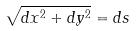Convert formula to latex. <formula><loc_0><loc_0><loc_500><loc_500>\sqrt { d x ^ { 2 } + d y ^ { 2 } } = d s</formula> 